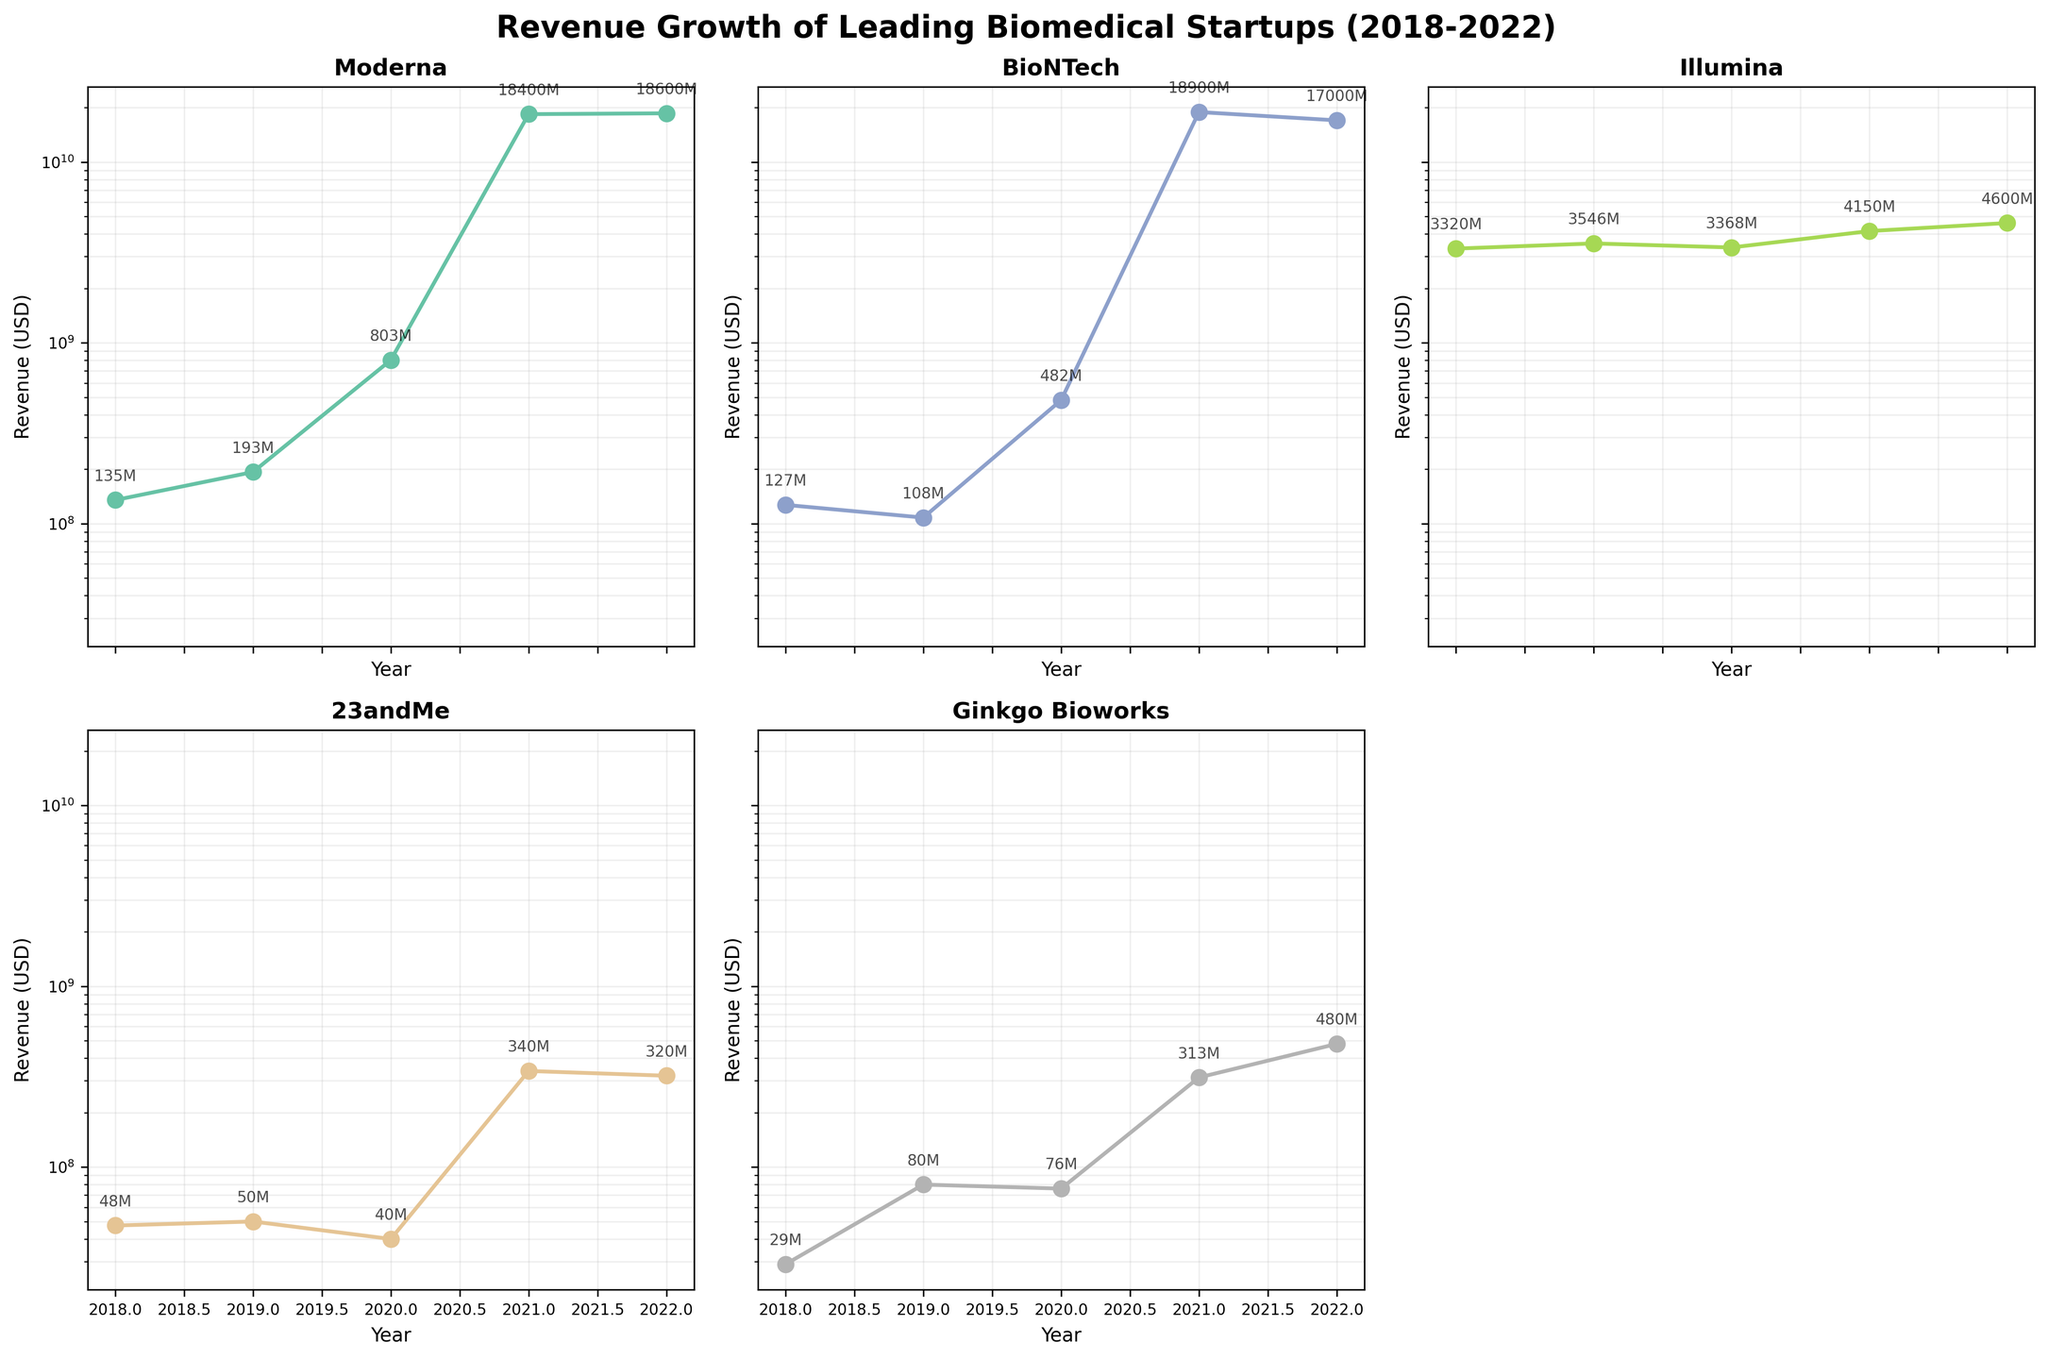What is the title of the figure? The title is displayed at the top of the figure in larger font and bold styling. It reads "Revenue Growth of Leading Biomedical Startups (2018-2022)."
Answer: Revenue Growth of Leading Biomedical Startups (2018-2022) How many companies' revenue data are shown in the figure? By looking at the subplots, we can count the distinct titles. There are 5 such titles, indicating 5 companies.
Answer: 5 Which company had the highest revenue in 2021? By observing the subplot titles and revenue values for 2021, BioNTech leads with approximately $18.9 billion, closely followed by Moderna.
Answer: BioNTech What is the revenue growth pattern for 23andMe from 2018 to 2022? Observing the subplot for 23andMe, we see it started at $47.5 million in 2018, peaked at $340 million in 2021, then slightly decreased to $320 million in 2022.
Answer: Growth until 2021, slight decline in 2022 How does Ginkgo Bioworks' revenue growth compare to Illumina's from 2020 to 2022? For Ginkgo Bioworks, revenue grew from $76 million in 2020 to $480 million in 2022. For Illumina, it increased from about $3.37 billion to $4.60 billion over the same period. Ginkgo Bioworks shows a higher growth rate.
Answer: Ginkgo Bioworks grew faster Which company showed the most exponential growth between 2018 and 2022? By examining the steepest curve on the log scale, Moderna and BioNTech show exponential growth from lower millions to tens of billions, with a more dramatic rise seen in Moderna starting 2021.
Answer: Moderna What was the total revenue of Moderna and BioNTech combined in 2020? According to their subplots, Moderna's 2020 revenue was $803 million, and BioNTech's was $482 million. Adding these gives 803 + 482 = $1.285 billion.
Answer: $1.285 billion Which company had the least revenue in 2019? Checking the subplots, Ginkgo Bioworks had the least revenue in 2019, approximately $80 million.
Answer: Ginkgo Bioworks What trend do you observe in Illumina's revenue over the five years? Illumina’s subplot shows a consistent upward trend from approximately $3.32 billion in 2018 to $4.60 billion in 2022.
Answer: Consistent upward trend Did any company's revenue decline between consecutive years? If so, which ones and when? Observing each subplot, Illumina decreased from 2019 to 2020, and 23andMe dropped from 2019 to 2020. BioNTech also slightly declined from 2018 to 2019.
Answer: Illumina (2019-2020), 23andMe (2019-2020), BioNTech (2018-2019) 